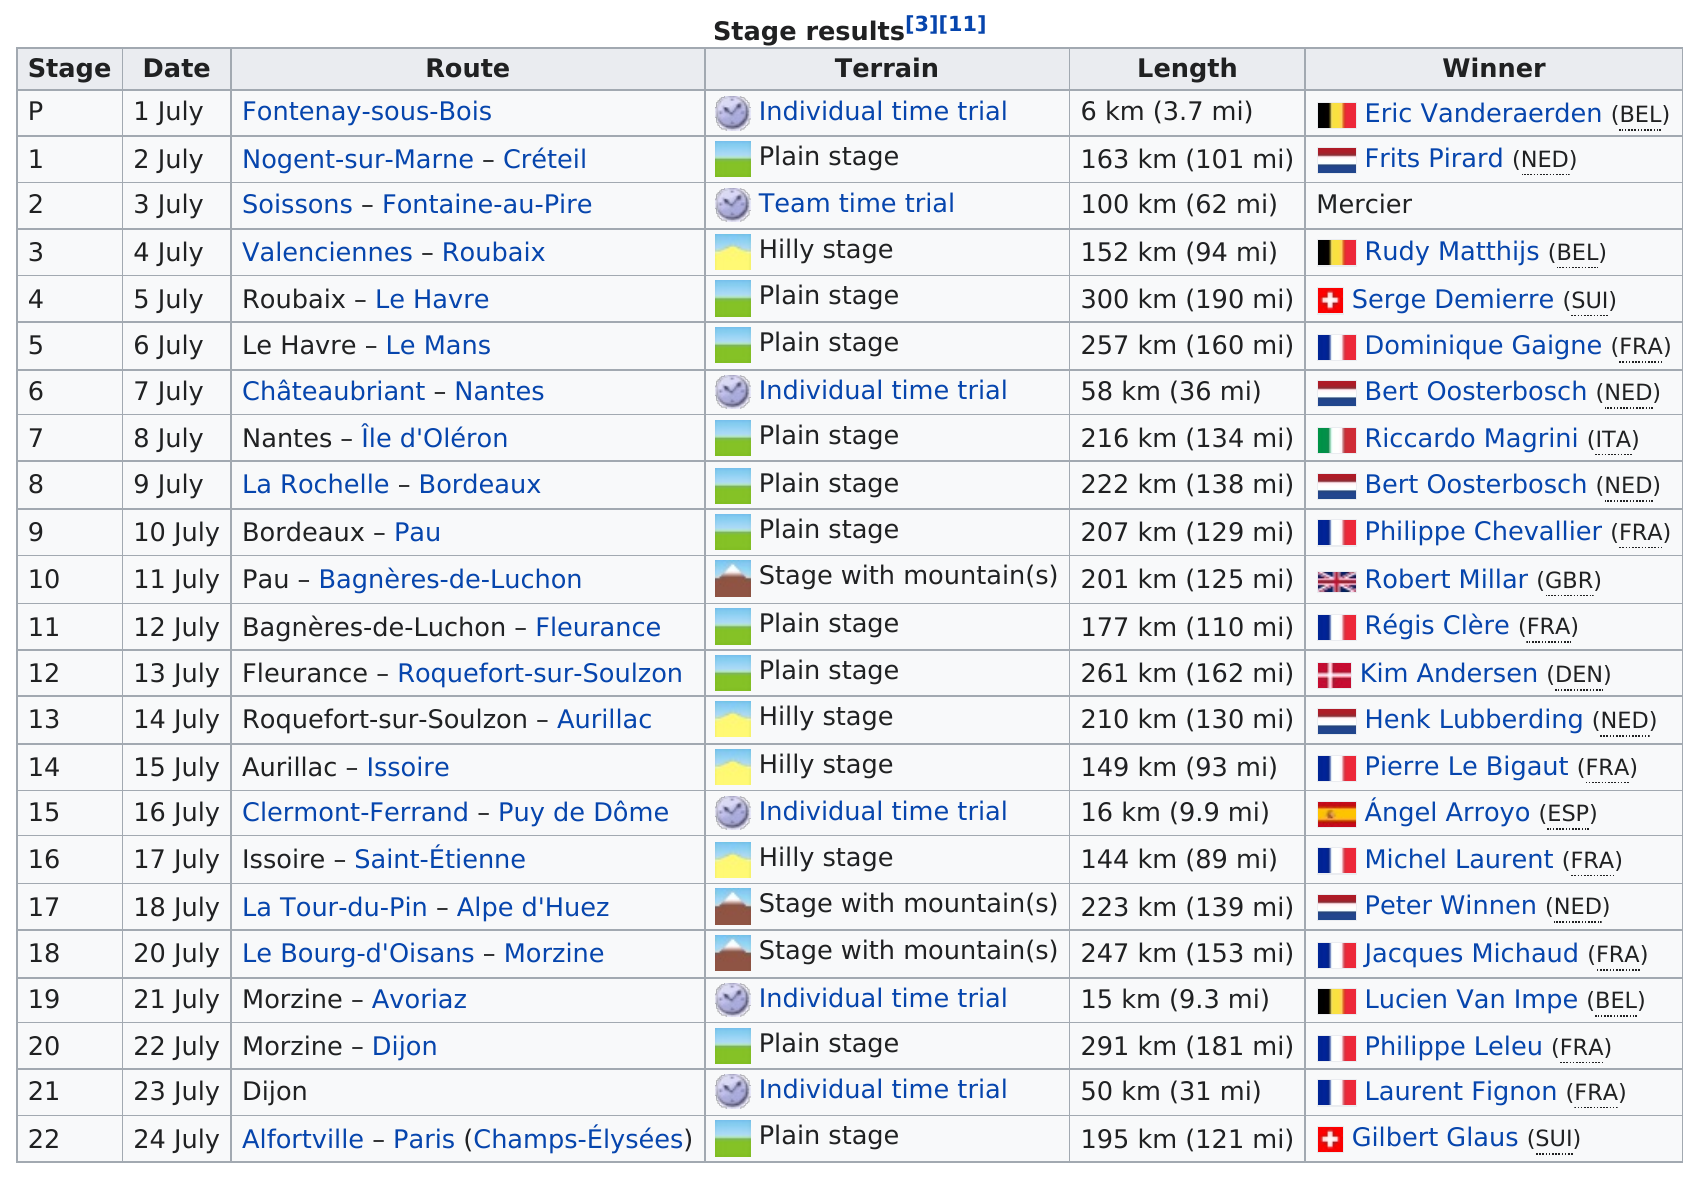Identify some key points in this picture. The total number of days for the tour was 23. Frits Pirard has won less than Bert Oosterbosch. Robert Millar did not win before Serge Demierre. During the 1983 Tour de France, there were 22 stages. The 1983 Tour de France comprised 22 stages. 